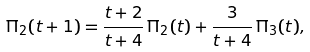Convert formula to latex. <formula><loc_0><loc_0><loc_500><loc_500>\Pi _ { 2 } ( t + 1 ) = \frac { t + 2 } { t + 4 } \, \Pi _ { 2 } ( t ) + \frac { 3 } { t + 4 } \, \Pi _ { 3 } ( t ) ,</formula> 